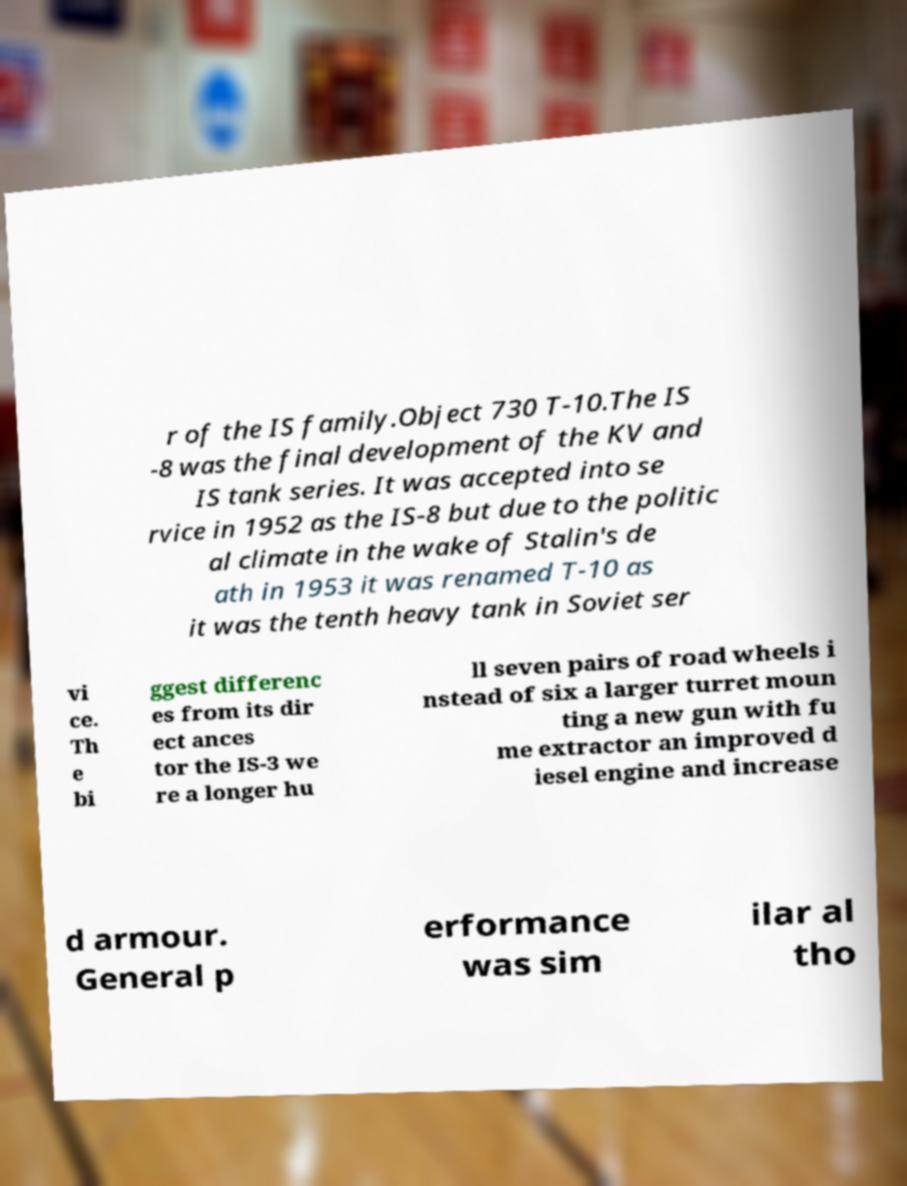Please read and relay the text visible in this image. What does it say? r of the IS family.Object 730 T-10.The IS -8 was the final development of the KV and IS tank series. It was accepted into se rvice in 1952 as the IS-8 but due to the politic al climate in the wake of Stalin's de ath in 1953 it was renamed T-10 as it was the tenth heavy tank in Soviet ser vi ce. Th e bi ggest differenc es from its dir ect ances tor the IS-3 we re a longer hu ll seven pairs of road wheels i nstead of six a larger turret moun ting a new gun with fu me extractor an improved d iesel engine and increase d armour. General p erformance was sim ilar al tho 